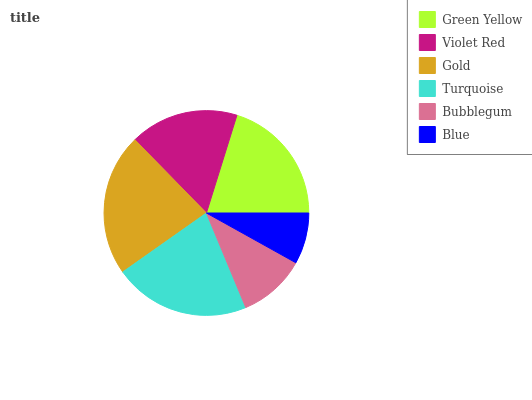Is Blue the minimum?
Answer yes or no. Yes. Is Gold the maximum?
Answer yes or no. Yes. Is Violet Red the minimum?
Answer yes or no. No. Is Violet Red the maximum?
Answer yes or no. No. Is Green Yellow greater than Violet Red?
Answer yes or no. Yes. Is Violet Red less than Green Yellow?
Answer yes or no. Yes. Is Violet Red greater than Green Yellow?
Answer yes or no. No. Is Green Yellow less than Violet Red?
Answer yes or no. No. Is Green Yellow the high median?
Answer yes or no. Yes. Is Violet Red the low median?
Answer yes or no. Yes. Is Violet Red the high median?
Answer yes or no. No. Is Gold the low median?
Answer yes or no. No. 